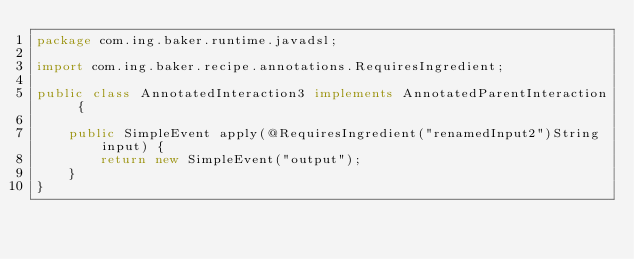Convert code to text. <code><loc_0><loc_0><loc_500><loc_500><_Java_>package com.ing.baker.runtime.javadsl;

import com.ing.baker.recipe.annotations.RequiresIngredient;

public class AnnotatedInteraction3 implements AnnotatedParentInteraction {

    public SimpleEvent apply(@RequiresIngredient("renamedInput2")String input) {
        return new SimpleEvent("output");
    }
}
</code> 